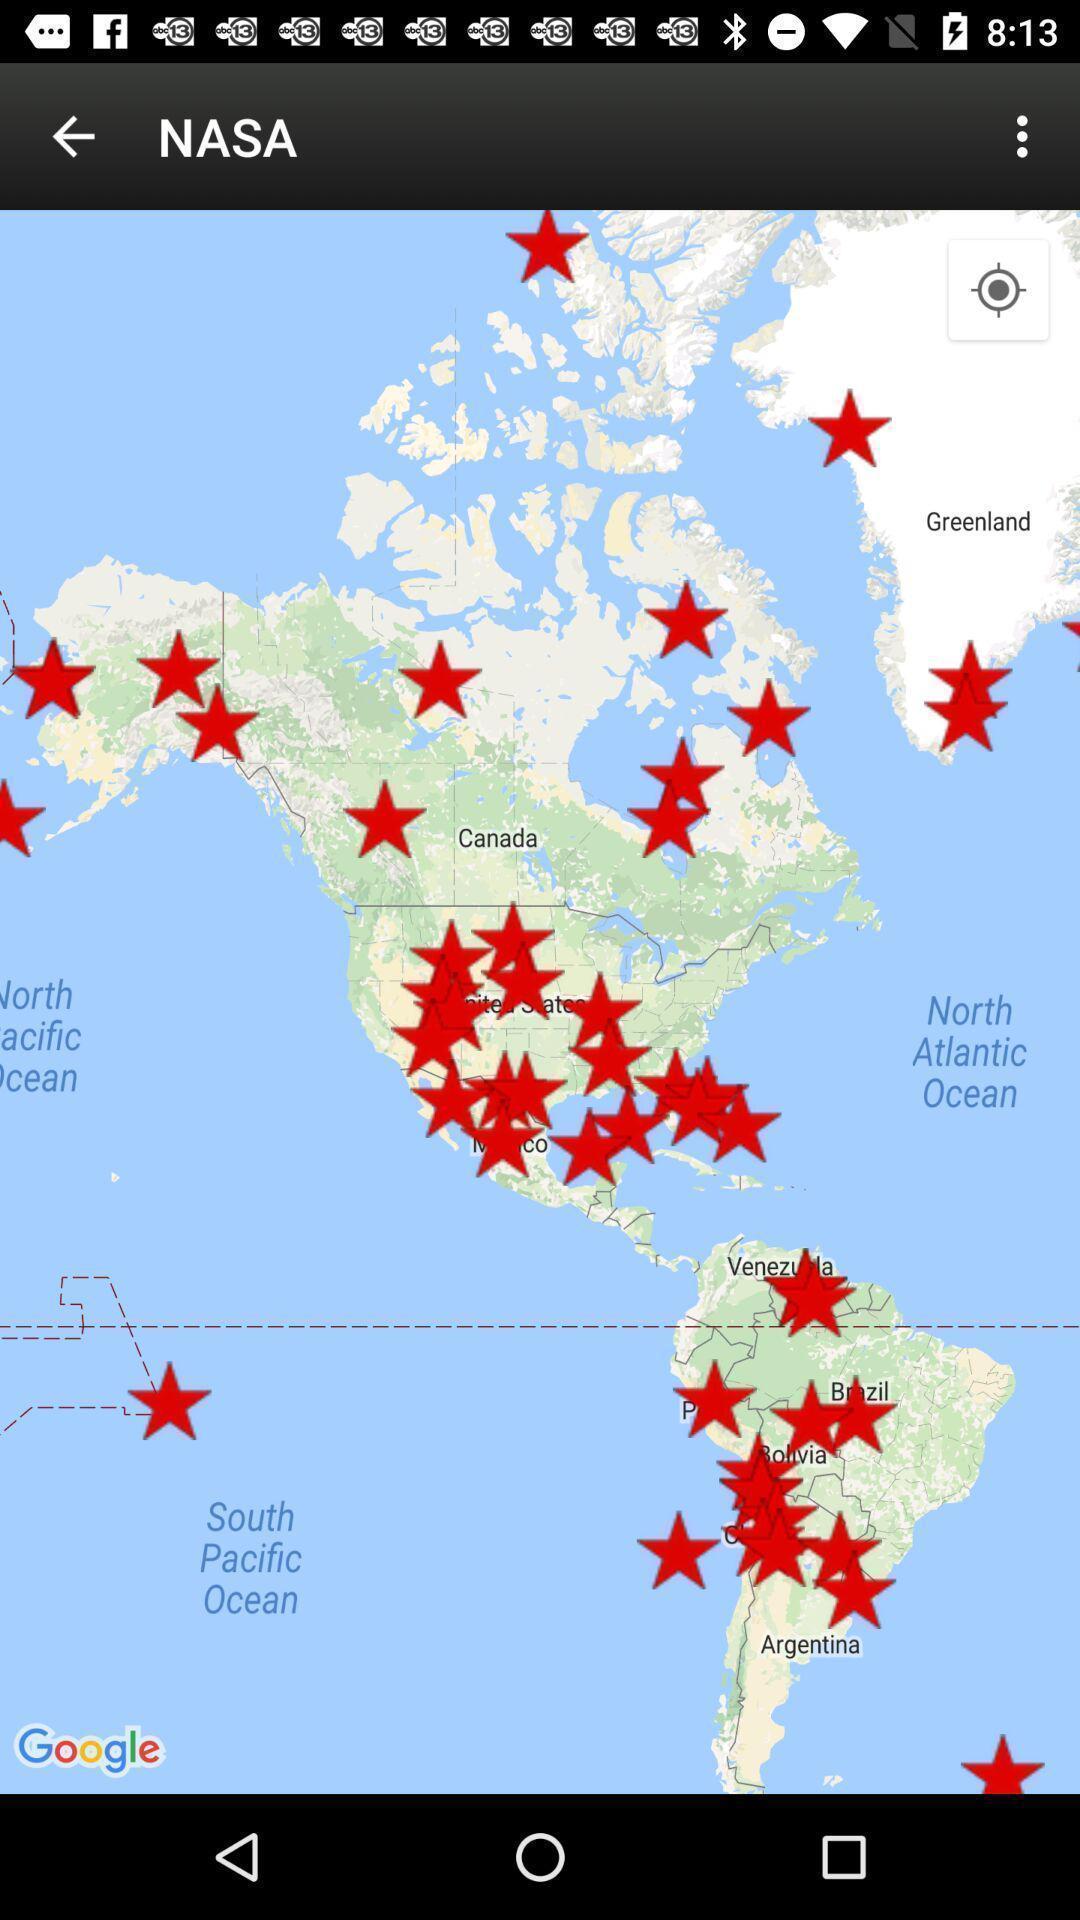Explain what's happening in this screen capture. Screen shows map view in a navigation app. 